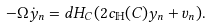Convert formula to latex. <formula><loc_0><loc_0><loc_500><loc_500>- \Omega \dot { y } _ { n } = d H _ { C } ( 2 c _ { \mathbb { H } } ( C ) y _ { n } + v _ { n } ) .</formula> 